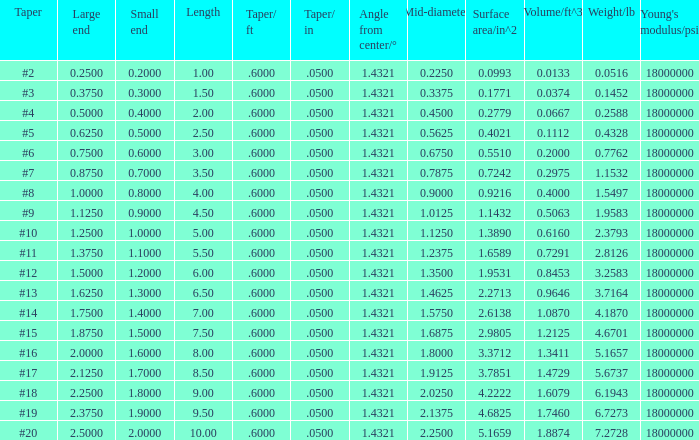Which Angle from center/° has a Taper/ft smaller than 0.6000000000000001? 19.0. 